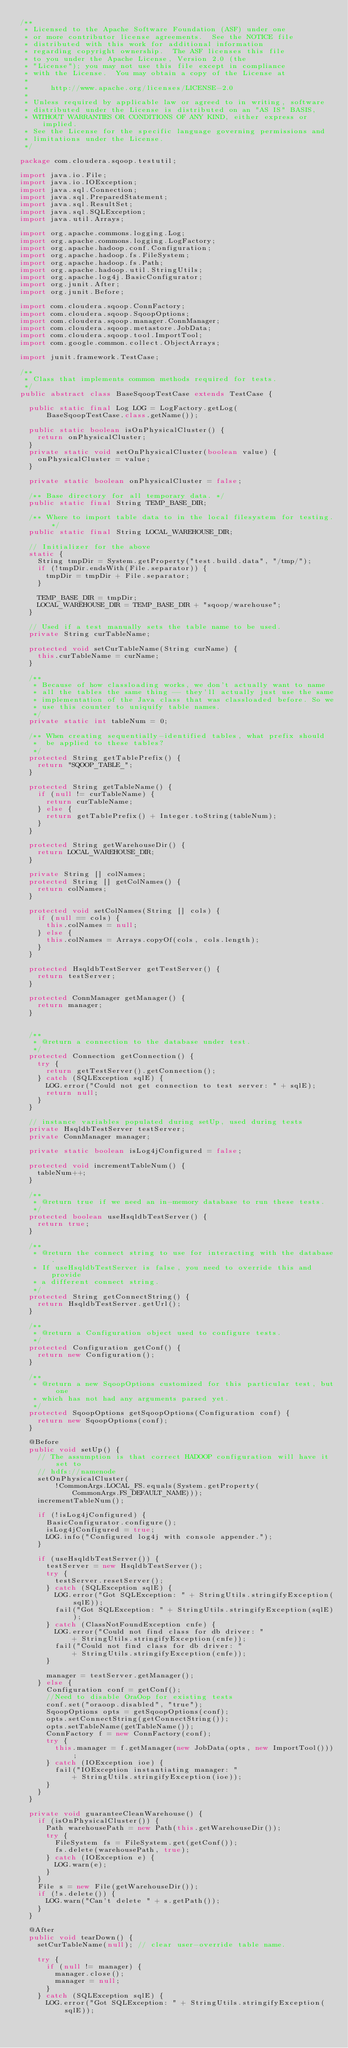Convert code to text. <code><loc_0><loc_0><loc_500><loc_500><_Java_>/**
 * Licensed to the Apache Software Foundation (ASF) under one
 * or more contributor license agreements.  See the NOTICE file
 * distributed with this work for additional information
 * regarding copyright ownership.  The ASF licenses this file
 * to you under the Apache License, Version 2.0 (the
 * "License"); you may not use this file except in compliance
 * with the License.  You may obtain a copy of the License at
 *
 *     http://www.apache.org/licenses/LICENSE-2.0
 *
 * Unless required by applicable law or agreed to in writing, software
 * distributed under the License is distributed on an "AS IS" BASIS,
 * WITHOUT WARRANTIES OR CONDITIONS OF ANY KIND, either express or implied.
 * See the License for the specific language governing permissions and
 * limitations under the License.
 */

package com.cloudera.sqoop.testutil;

import java.io.File;
import java.io.IOException;
import java.sql.Connection;
import java.sql.PreparedStatement;
import java.sql.ResultSet;
import java.sql.SQLException;
import java.util.Arrays;

import org.apache.commons.logging.Log;
import org.apache.commons.logging.LogFactory;
import org.apache.hadoop.conf.Configuration;
import org.apache.hadoop.fs.FileSystem;
import org.apache.hadoop.fs.Path;
import org.apache.hadoop.util.StringUtils;
import org.apache.log4j.BasicConfigurator;
import org.junit.After;
import org.junit.Before;

import com.cloudera.sqoop.ConnFactory;
import com.cloudera.sqoop.SqoopOptions;
import com.cloudera.sqoop.manager.ConnManager;
import com.cloudera.sqoop.metastore.JobData;
import com.cloudera.sqoop.tool.ImportTool;
import com.google.common.collect.ObjectArrays;

import junit.framework.TestCase;

/**
 * Class that implements common methods required for tests.
 */
public abstract class BaseSqoopTestCase extends TestCase {

  public static final Log LOG = LogFactory.getLog(
      BaseSqoopTestCase.class.getName());

  public static boolean isOnPhysicalCluster() {
    return onPhysicalCluster;
  }
  private static void setOnPhysicalCluster(boolean value) {
    onPhysicalCluster = value;
  }

  private static boolean onPhysicalCluster = false;

  /** Base directory for all temporary data. */
  public static final String TEMP_BASE_DIR;

  /** Where to import table data to in the local filesystem for testing. */
  public static final String LOCAL_WAREHOUSE_DIR;

  // Initializer for the above
  static {
    String tmpDir = System.getProperty("test.build.data", "/tmp/");
    if (!tmpDir.endsWith(File.separator)) {
      tmpDir = tmpDir + File.separator;
    }

    TEMP_BASE_DIR = tmpDir;
    LOCAL_WAREHOUSE_DIR = TEMP_BASE_DIR + "sqoop/warehouse";
  }

  // Used if a test manually sets the table name to be used.
  private String curTableName;

  protected void setCurTableName(String curName) {
    this.curTableName = curName;
  }

  /**
   * Because of how classloading works, we don't actually want to name
   * all the tables the same thing -- they'll actually just use the same
   * implementation of the Java class that was classloaded before. So we
   * use this counter to uniquify table names.
   */
  private static int tableNum = 0;

  /** When creating sequentially-identified tables, what prefix should
   *  be applied to these tables?
   */
  protected String getTablePrefix() {
    return "SQOOP_TABLE_";
  }

  protected String getTableName() {
    if (null != curTableName) {
      return curTableName;
    } else {
      return getTablePrefix() + Integer.toString(tableNum);
    }
  }

  protected String getWarehouseDir() {
    return LOCAL_WAREHOUSE_DIR;
  }

  private String [] colNames;
  protected String [] getColNames() {
    return colNames;
  }

  protected void setColNames(String [] cols) {
    if (null == cols) {
      this.colNames = null;
    } else {
      this.colNames = Arrays.copyOf(cols, cols.length);
    }
  }

  protected HsqldbTestServer getTestServer() {
    return testServer;
  }

  protected ConnManager getManager() {
    return manager;
  }


  /**
   * @return a connection to the database under test.
   */
  protected Connection getConnection() {
    try {
      return getTestServer().getConnection();
    } catch (SQLException sqlE) {
      LOG.error("Could not get connection to test server: " + sqlE);
      return null;
    }
  }

  // instance variables populated during setUp, used during tests
  private HsqldbTestServer testServer;
  private ConnManager manager;

  private static boolean isLog4jConfigured = false;

  protected void incrementTableNum() {
    tableNum++;
  }

  /**
   * @return true if we need an in-memory database to run these tests.
   */
  protected boolean useHsqldbTestServer() {
    return true;
  }

  /**
   * @return the connect string to use for interacting with the database.
   * If useHsqldbTestServer is false, you need to override this and provide
   * a different connect string.
   */
  protected String getConnectString() {
    return HsqldbTestServer.getUrl();
  }

  /**
   * @return a Configuration object used to configure tests.
   */
  protected Configuration getConf() {
    return new Configuration();
  }

  /**
   * @return a new SqoopOptions customized for this particular test, but one
   * which has not had any arguments parsed yet.
   */
  protected SqoopOptions getSqoopOptions(Configuration conf) {
    return new SqoopOptions(conf);
  }

  @Before
  public void setUp() {
    // The assumption is that correct HADOOP configuration will have it set to
    // hdfs://namenode
    setOnPhysicalCluster(
        !CommonArgs.LOCAL_FS.equals(System.getProperty(
            CommonArgs.FS_DEFAULT_NAME)));
    incrementTableNum();

    if (!isLog4jConfigured) {
      BasicConfigurator.configure();
      isLog4jConfigured = true;
      LOG.info("Configured log4j with console appender.");
    }

    if (useHsqldbTestServer()) {
      testServer = new HsqldbTestServer();
      try {
        testServer.resetServer();
      } catch (SQLException sqlE) {
        LOG.error("Got SQLException: " + StringUtils.stringifyException(sqlE));
        fail("Got SQLException: " + StringUtils.stringifyException(sqlE));
      } catch (ClassNotFoundException cnfe) {
        LOG.error("Could not find class for db driver: "
            + StringUtils.stringifyException(cnfe));
        fail("Could not find class for db driver: "
            + StringUtils.stringifyException(cnfe));
      }

      manager = testServer.getManager();
    } else {
      Configuration conf = getConf();
      //Need to disable OraOop for existing tests
      conf.set("oraoop.disabled", "true");
      SqoopOptions opts = getSqoopOptions(conf);
      opts.setConnectString(getConnectString());
      opts.setTableName(getTableName());
      ConnFactory f = new ConnFactory(conf);
      try {
        this.manager = f.getManager(new JobData(opts, new ImportTool()));
      } catch (IOException ioe) {
        fail("IOException instantiating manager: "
            + StringUtils.stringifyException(ioe));
      }
    }
  }

  private void guaranteeCleanWarehouse() {
    if (isOnPhysicalCluster()) {
      Path warehousePath = new Path(this.getWarehouseDir());
      try {
        FileSystem fs = FileSystem.get(getConf());
        fs.delete(warehousePath, true);
      } catch (IOException e) {
        LOG.warn(e);
      }
    }
    File s = new File(getWarehouseDir());
    if (!s.delete()) {
      LOG.warn("Can't delete " + s.getPath());
    }
  }

  @After
  public void tearDown() {
    setCurTableName(null); // clear user-override table name.

    try {
      if (null != manager) {
        manager.close();
        manager = null;
      }
    } catch (SQLException sqlE) {
      LOG.error("Got SQLException: " + StringUtils.stringifyException(sqlE));</code> 